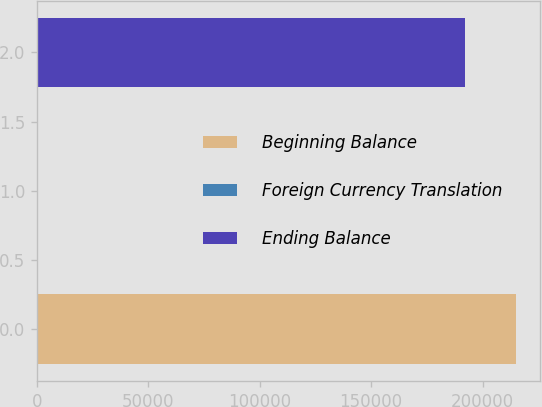Convert chart. <chart><loc_0><loc_0><loc_500><loc_500><bar_chart><fcel>Beginning Balance<fcel>Foreign Currency Translation<fcel>Ending Balance<nl><fcel>215245<fcel>532<fcel>191929<nl></chart> 